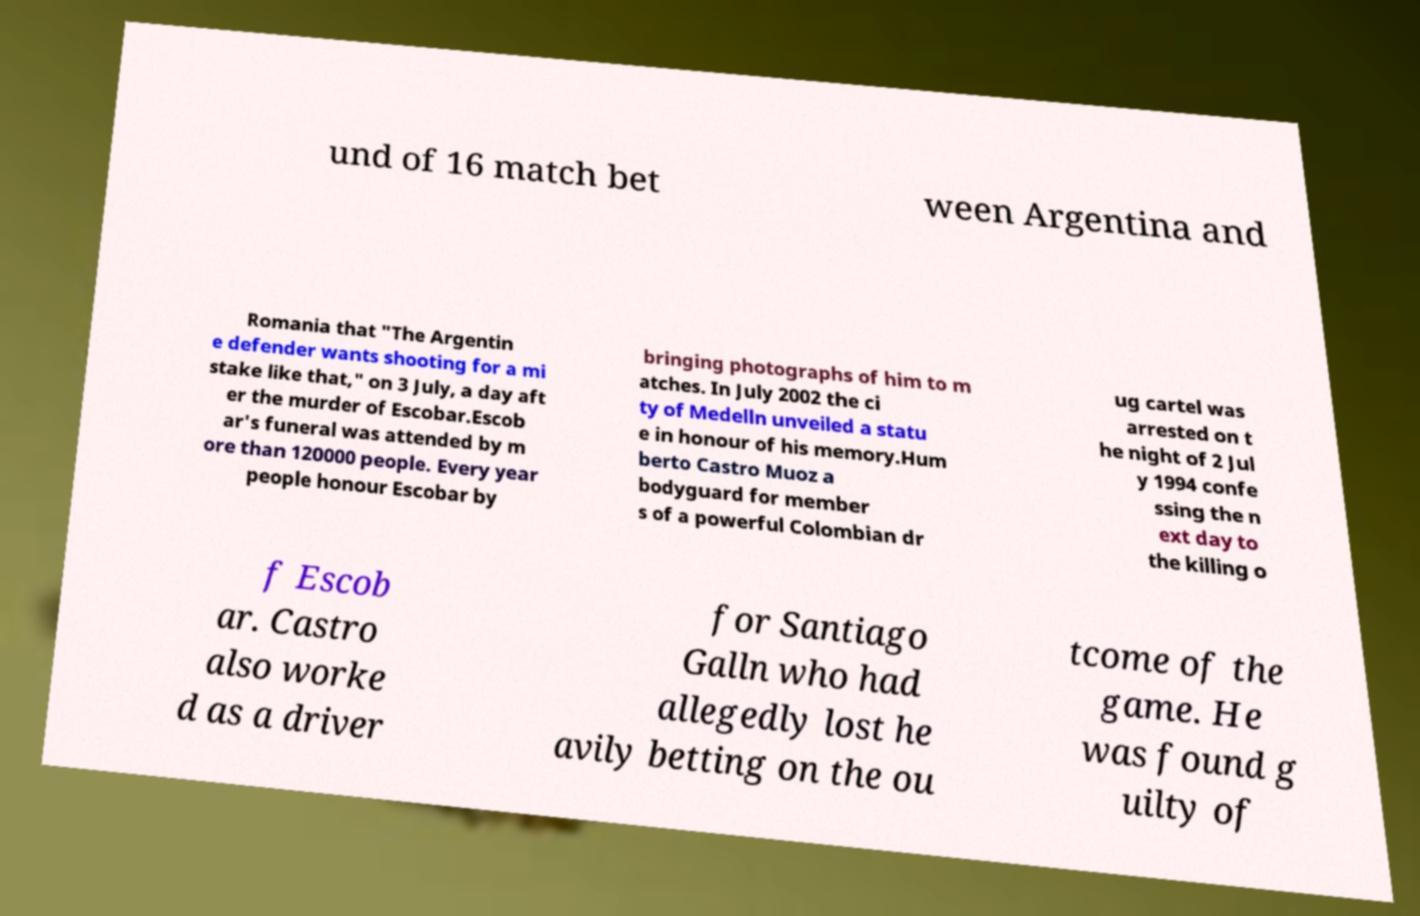What messages or text are displayed in this image? I need them in a readable, typed format. und of 16 match bet ween Argentina and Romania that "The Argentin e defender wants shooting for a mi stake like that," on 3 July, a day aft er the murder of Escobar.Escob ar's funeral was attended by m ore than 120000 people. Every year people honour Escobar by bringing photographs of him to m atches. In July 2002 the ci ty of Medelln unveiled a statu e in honour of his memory.Hum berto Castro Muoz a bodyguard for member s of a powerful Colombian dr ug cartel was arrested on t he night of 2 Jul y 1994 confe ssing the n ext day to the killing o f Escob ar. Castro also worke d as a driver for Santiago Galln who had allegedly lost he avily betting on the ou tcome of the game. He was found g uilty of 